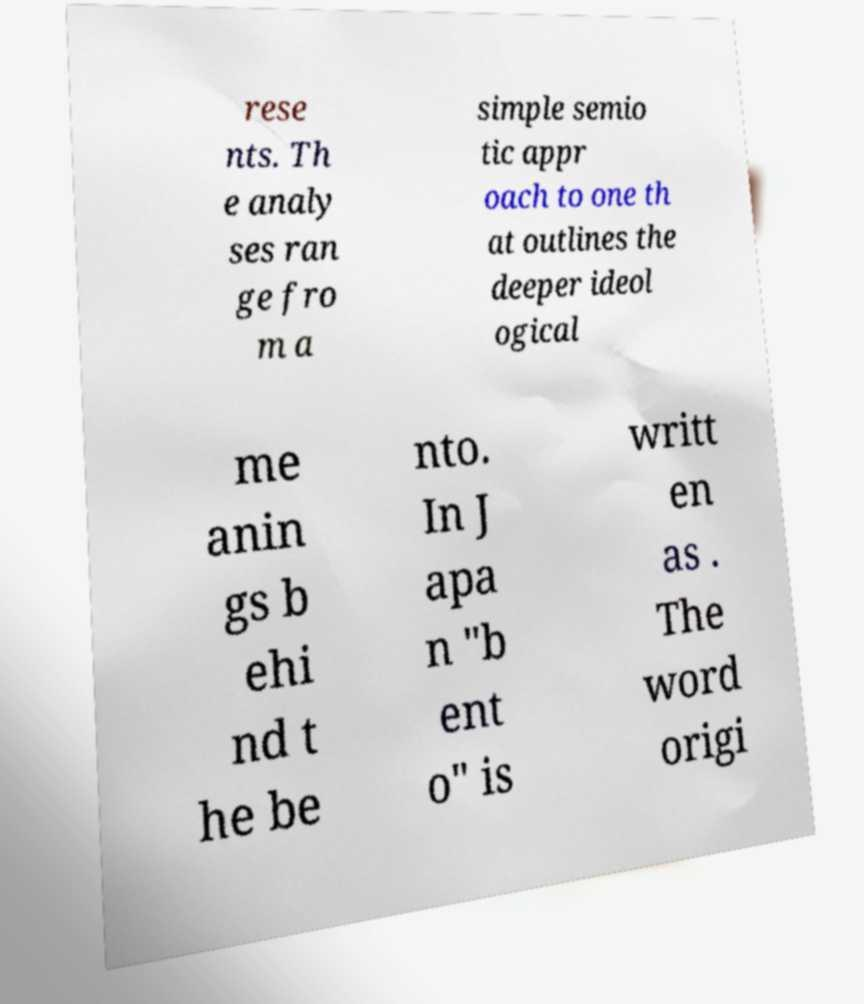Could you extract and type out the text from this image? rese nts. Th e analy ses ran ge fro m a simple semio tic appr oach to one th at outlines the deeper ideol ogical me anin gs b ehi nd t he be nto. In J apa n "b ent o" is writt en as . The word origi 